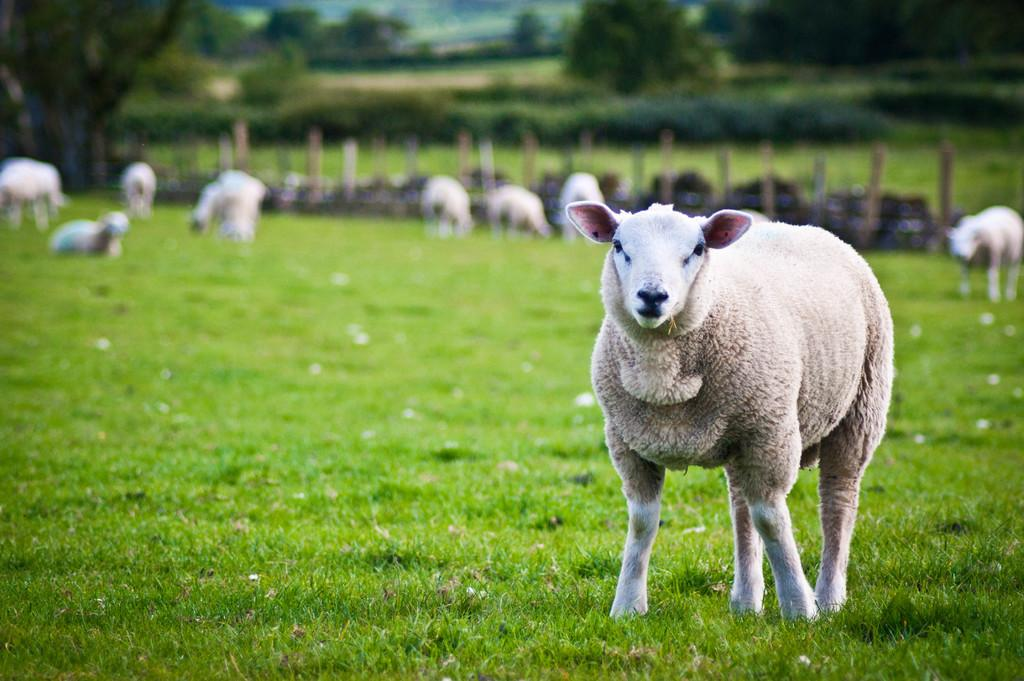What color is the animal in the image? The animal in the image is white. What are the other animals in the image doing? The other animals in the background are eating grass. What type of vegetation is visible in the image? There is grass visible in the image, and trees can be seen in the background. What color are the grass and trees? The grass and trees are in green color. Can you tell me how many oranges are on the tree in the image? There are no oranges present in the image; it features animals and vegetation in a grassy area. Is there a bag visible in the image? There is no bag present in the image. 